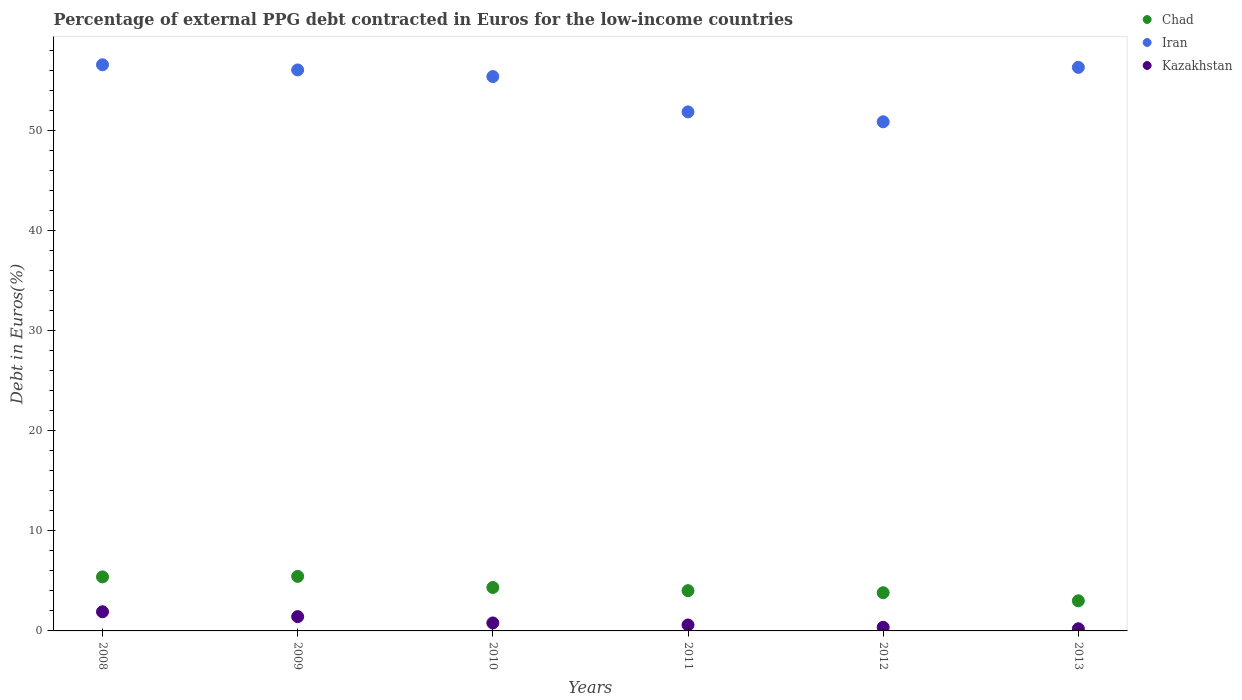Is the number of dotlines equal to the number of legend labels?
Provide a succinct answer. Yes. What is the percentage of external PPG debt contracted in Euros in Chad in 2012?
Your answer should be very brief. 3.82. Across all years, what is the maximum percentage of external PPG debt contracted in Euros in Iran?
Keep it short and to the point. 56.53. Across all years, what is the minimum percentage of external PPG debt contracted in Euros in Chad?
Your response must be concise. 3.01. In which year was the percentage of external PPG debt contracted in Euros in Kazakhstan maximum?
Your answer should be compact. 2008. What is the total percentage of external PPG debt contracted in Euros in Chad in the graph?
Provide a short and direct response. 26.02. What is the difference between the percentage of external PPG debt contracted in Euros in Iran in 2009 and that in 2011?
Keep it short and to the point. 4.19. What is the difference between the percentage of external PPG debt contracted in Euros in Iran in 2011 and the percentage of external PPG debt contracted in Euros in Kazakhstan in 2012?
Your answer should be very brief. 51.47. What is the average percentage of external PPG debt contracted in Euros in Kazakhstan per year?
Provide a short and direct response. 0.88. In the year 2012, what is the difference between the percentage of external PPG debt contracted in Euros in Chad and percentage of external PPG debt contracted in Euros in Iran?
Give a very brief answer. -47.02. In how many years, is the percentage of external PPG debt contracted in Euros in Chad greater than 42 %?
Give a very brief answer. 0. What is the ratio of the percentage of external PPG debt contracted in Euros in Chad in 2010 to that in 2011?
Provide a succinct answer. 1.08. Is the percentage of external PPG debt contracted in Euros in Chad in 2009 less than that in 2012?
Provide a succinct answer. No. Is the difference between the percentage of external PPG debt contracted in Euros in Chad in 2011 and 2013 greater than the difference between the percentage of external PPG debt contracted in Euros in Iran in 2011 and 2013?
Provide a short and direct response. Yes. What is the difference between the highest and the second highest percentage of external PPG debt contracted in Euros in Chad?
Keep it short and to the point. 0.05. What is the difference between the highest and the lowest percentage of external PPG debt contracted in Euros in Kazakhstan?
Your response must be concise. 1.7. Is the percentage of external PPG debt contracted in Euros in Iran strictly greater than the percentage of external PPG debt contracted in Euros in Chad over the years?
Provide a succinct answer. Yes. How many years are there in the graph?
Offer a terse response. 6. What is the difference between two consecutive major ticks on the Y-axis?
Make the answer very short. 10. Does the graph contain any zero values?
Offer a terse response. No. Does the graph contain grids?
Provide a succinct answer. No. How many legend labels are there?
Offer a very short reply. 3. How are the legend labels stacked?
Make the answer very short. Vertical. What is the title of the graph?
Your answer should be compact. Percentage of external PPG debt contracted in Euros for the low-income countries. Does "Antigua and Barbuda" appear as one of the legend labels in the graph?
Offer a terse response. No. What is the label or title of the X-axis?
Provide a short and direct response. Years. What is the label or title of the Y-axis?
Provide a succinct answer. Debt in Euros(%). What is the Debt in Euros(%) of Chad in 2008?
Your response must be concise. 5.39. What is the Debt in Euros(%) of Iran in 2008?
Provide a short and direct response. 56.53. What is the Debt in Euros(%) of Kazakhstan in 2008?
Offer a terse response. 1.91. What is the Debt in Euros(%) of Chad in 2009?
Provide a short and direct response. 5.44. What is the Debt in Euros(%) in Iran in 2009?
Offer a very short reply. 56.01. What is the Debt in Euros(%) in Kazakhstan in 2009?
Your response must be concise. 1.43. What is the Debt in Euros(%) of Chad in 2010?
Keep it short and to the point. 4.34. What is the Debt in Euros(%) of Iran in 2010?
Provide a short and direct response. 55.35. What is the Debt in Euros(%) in Kazakhstan in 2010?
Ensure brevity in your answer.  0.8. What is the Debt in Euros(%) in Chad in 2011?
Your response must be concise. 4.02. What is the Debt in Euros(%) in Iran in 2011?
Provide a short and direct response. 51.83. What is the Debt in Euros(%) of Kazakhstan in 2011?
Keep it short and to the point. 0.59. What is the Debt in Euros(%) of Chad in 2012?
Keep it short and to the point. 3.82. What is the Debt in Euros(%) of Iran in 2012?
Keep it short and to the point. 50.84. What is the Debt in Euros(%) of Kazakhstan in 2012?
Your response must be concise. 0.36. What is the Debt in Euros(%) in Chad in 2013?
Your answer should be compact. 3.01. What is the Debt in Euros(%) of Iran in 2013?
Keep it short and to the point. 56.27. What is the Debt in Euros(%) of Kazakhstan in 2013?
Ensure brevity in your answer.  0.21. Across all years, what is the maximum Debt in Euros(%) in Chad?
Provide a succinct answer. 5.44. Across all years, what is the maximum Debt in Euros(%) in Iran?
Ensure brevity in your answer.  56.53. Across all years, what is the maximum Debt in Euros(%) in Kazakhstan?
Ensure brevity in your answer.  1.91. Across all years, what is the minimum Debt in Euros(%) in Chad?
Provide a short and direct response. 3.01. Across all years, what is the minimum Debt in Euros(%) of Iran?
Offer a terse response. 50.84. Across all years, what is the minimum Debt in Euros(%) in Kazakhstan?
Make the answer very short. 0.21. What is the total Debt in Euros(%) of Chad in the graph?
Give a very brief answer. 26.02. What is the total Debt in Euros(%) in Iran in the graph?
Your answer should be compact. 326.84. What is the total Debt in Euros(%) of Kazakhstan in the graph?
Ensure brevity in your answer.  5.31. What is the difference between the Debt in Euros(%) in Chad in 2008 and that in 2009?
Your answer should be very brief. -0.05. What is the difference between the Debt in Euros(%) of Iran in 2008 and that in 2009?
Your response must be concise. 0.52. What is the difference between the Debt in Euros(%) in Kazakhstan in 2008 and that in 2009?
Make the answer very short. 0.49. What is the difference between the Debt in Euros(%) in Chad in 2008 and that in 2010?
Provide a short and direct response. 1.06. What is the difference between the Debt in Euros(%) in Iran in 2008 and that in 2010?
Your answer should be compact. 1.18. What is the difference between the Debt in Euros(%) of Kazakhstan in 2008 and that in 2010?
Make the answer very short. 1.12. What is the difference between the Debt in Euros(%) of Chad in 2008 and that in 2011?
Your answer should be very brief. 1.37. What is the difference between the Debt in Euros(%) of Iran in 2008 and that in 2011?
Your answer should be compact. 4.7. What is the difference between the Debt in Euros(%) in Kazakhstan in 2008 and that in 2011?
Ensure brevity in your answer.  1.32. What is the difference between the Debt in Euros(%) of Chad in 2008 and that in 2012?
Give a very brief answer. 1.58. What is the difference between the Debt in Euros(%) in Iran in 2008 and that in 2012?
Provide a succinct answer. 5.69. What is the difference between the Debt in Euros(%) in Kazakhstan in 2008 and that in 2012?
Keep it short and to the point. 1.55. What is the difference between the Debt in Euros(%) in Chad in 2008 and that in 2013?
Your answer should be very brief. 2.39. What is the difference between the Debt in Euros(%) in Iran in 2008 and that in 2013?
Offer a very short reply. 0.26. What is the difference between the Debt in Euros(%) in Kazakhstan in 2008 and that in 2013?
Your answer should be very brief. 1.7. What is the difference between the Debt in Euros(%) in Chad in 2009 and that in 2010?
Provide a short and direct response. 1.11. What is the difference between the Debt in Euros(%) in Iran in 2009 and that in 2010?
Your answer should be compact. 0.66. What is the difference between the Debt in Euros(%) in Kazakhstan in 2009 and that in 2010?
Make the answer very short. 0.63. What is the difference between the Debt in Euros(%) of Chad in 2009 and that in 2011?
Provide a short and direct response. 1.42. What is the difference between the Debt in Euros(%) of Iran in 2009 and that in 2011?
Your answer should be very brief. 4.19. What is the difference between the Debt in Euros(%) in Kazakhstan in 2009 and that in 2011?
Offer a terse response. 0.83. What is the difference between the Debt in Euros(%) of Chad in 2009 and that in 2012?
Provide a short and direct response. 1.63. What is the difference between the Debt in Euros(%) in Iran in 2009 and that in 2012?
Provide a succinct answer. 5.18. What is the difference between the Debt in Euros(%) of Kazakhstan in 2009 and that in 2012?
Your response must be concise. 1.06. What is the difference between the Debt in Euros(%) of Chad in 2009 and that in 2013?
Provide a short and direct response. 2.44. What is the difference between the Debt in Euros(%) of Iran in 2009 and that in 2013?
Your response must be concise. -0.26. What is the difference between the Debt in Euros(%) of Kazakhstan in 2009 and that in 2013?
Ensure brevity in your answer.  1.21. What is the difference between the Debt in Euros(%) of Chad in 2010 and that in 2011?
Your answer should be compact. 0.31. What is the difference between the Debt in Euros(%) in Iran in 2010 and that in 2011?
Offer a very short reply. 3.53. What is the difference between the Debt in Euros(%) in Kazakhstan in 2010 and that in 2011?
Offer a terse response. 0.2. What is the difference between the Debt in Euros(%) in Chad in 2010 and that in 2012?
Keep it short and to the point. 0.52. What is the difference between the Debt in Euros(%) in Iran in 2010 and that in 2012?
Give a very brief answer. 4.52. What is the difference between the Debt in Euros(%) in Kazakhstan in 2010 and that in 2012?
Your answer should be compact. 0.43. What is the difference between the Debt in Euros(%) of Chad in 2010 and that in 2013?
Offer a very short reply. 1.33. What is the difference between the Debt in Euros(%) in Iran in 2010 and that in 2013?
Offer a terse response. -0.92. What is the difference between the Debt in Euros(%) in Kazakhstan in 2010 and that in 2013?
Make the answer very short. 0.58. What is the difference between the Debt in Euros(%) in Chad in 2011 and that in 2012?
Make the answer very short. 0.21. What is the difference between the Debt in Euros(%) in Kazakhstan in 2011 and that in 2012?
Keep it short and to the point. 0.23. What is the difference between the Debt in Euros(%) of Chad in 2011 and that in 2013?
Give a very brief answer. 1.01. What is the difference between the Debt in Euros(%) in Iran in 2011 and that in 2013?
Your response must be concise. -4.44. What is the difference between the Debt in Euros(%) in Kazakhstan in 2011 and that in 2013?
Provide a succinct answer. 0.38. What is the difference between the Debt in Euros(%) of Chad in 2012 and that in 2013?
Your response must be concise. 0.81. What is the difference between the Debt in Euros(%) in Iran in 2012 and that in 2013?
Provide a succinct answer. -5.43. What is the difference between the Debt in Euros(%) in Kazakhstan in 2012 and that in 2013?
Ensure brevity in your answer.  0.15. What is the difference between the Debt in Euros(%) in Chad in 2008 and the Debt in Euros(%) in Iran in 2009?
Provide a succinct answer. -50.62. What is the difference between the Debt in Euros(%) in Chad in 2008 and the Debt in Euros(%) in Kazakhstan in 2009?
Offer a very short reply. 3.97. What is the difference between the Debt in Euros(%) in Iran in 2008 and the Debt in Euros(%) in Kazakhstan in 2009?
Provide a succinct answer. 55.1. What is the difference between the Debt in Euros(%) in Chad in 2008 and the Debt in Euros(%) in Iran in 2010?
Provide a short and direct response. -49.96. What is the difference between the Debt in Euros(%) in Chad in 2008 and the Debt in Euros(%) in Kazakhstan in 2010?
Offer a terse response. 4.6. What is the difference between the Debt in Euros(%) in Iran in 2008 and the Debt in Euros(%) in Kazakhstan in 2010?
Make the answer very short. 55.73. What is the difference between the Debt in Euros(%) of Chad in 2008 and the Debt in Euros(%) of Iran in 2011?
Provide a succinct answer. -46.43. What is the difference between the Debt in Euros(%) in Chad in 2008 and the Debt in Euros(%) in Kazakhstan in 2011?
Ensure brevity in your answer.  4.8. What is the difference between the Debt in Euros(%) of Iran in 2008 and the Debt in Euros(%) of Kazakhstan in 2011?
Your answer should be very brief. 55.94. What is the difference between the Debt in Euros(%) of Chad in 2008 and the Debt in Euros(%) of Iran in 2012?
Your response must be concise. -45.44. What is the difference between the Debt in Euros(%) of Chad in 2008 and the Debt in Euros(%) of Kazakhstan in 2012?
Offer a very short reply. 5.03. What is the difference between the Debt in Euros(%) of Iran in 2008 and the Debt in Euros(%) of Kazakhstan in 2012?
Keep it short and to the point. 56.17. What is the difference between the Debt in Euros(%) of Chad in 2008 and the Debt in Euros(%) of Iran in 2013?
Your response must be concise. -50.88. What is the difference between the Debt in Euros(%) of Chad in 2008 and the Debt in Euros(%) of Kazakhstan in 2013?
Provide a short and direct response. 5.18. What is the difference between the Debt in Euros(%) in Iran in 2008 and the Debt in Euros(%) in Kazakhstan in 2013?
Your answer should be very brief. 56.32. What is the difference between the Debt in Euros(%) of Chad in 2009 and the Debt in Euros(%) of Iran in 2010?
Make the answer very short. -49.91. What is the difference between the Debt in Euros(%) in Chad in 2009 and the Debt in Euros(%) in Kazakhstan in 2010?
Your response must be concise. 4.65. What is the difference between the Debt in Euros(%) in Iran in 2009 and the Debt in Euros(%) in Kazakhstan in 2010?
Provide a succinct answer. 55.22. What is the difference between the Debt in Euros(%) in Chad in 2009 and the Debt in Euros(%) in Iran in 2011?
Give a very brief answer. -46.38. What is the difference between the Debt in Euros(%) in Chad in 2009 and the Debt in Euros(%) in Kazakhstan in 2011?
Provide a short and direct response. 4.85. What is the difference between the Debt in Euros(%) in Iran in 2009 and the Debt in Euros(%) in Kazakhstan in 2011?
Your answer should be compact. 55.42. What is the difference between the Debt in Euros(%) in Chad in 2009 and the Debt in Euros(%) in Iran in 2012?
Provide a succinct answer. -45.39. What is the difference between the Debt in Euros(%) in Chad in 2009 and the Debt in Euros(%) in Kazakhstan in 2012?
Offer a terse response. 5.08. What is the difference between the Debt in Euros(%) in Iran in 2009 and the Debt in Euros(%) in Kazakhstan in 2012?
Provide a short and direct response. 55.65. What is the difference between the Debt in Euros(%) of Chad in 2009 and the Debt in Euros(%) of Iran in 2013?
Your answer should be very brief. -50.83. What is the difference between the Debt in Euros(%) of Chad in 2009 and the Debt in Euros(%) of Kazakhstan in 2013?
Provide a short and direct response. 5.23. What is the difference between the Debt in Euros(%) in Iran in 2009 and the Debt in Euros(%) in Kazakhstan in 2013?
Make the answer very short. 55.8. What is the difference between the Debt in Euros(%) in Chad in 2010 and the Debt in Euros(%) in Iran in 2011?
Your response must be concise. -47.49. What is the difference between the Debt in Euros(%) of Chad in 2010 and the Debt in Euros(%) of Kazakhstan in 2011?
Offer a very short reply. 3.74. What is the difference between the Debt in Euros(%) in Iran in 2010 and the Debt in Euros(%) in Kazakhstan in 2011?
Ensure brevity in your answer.  54.76. What is the difference between the Debt in Euros(%) of Chad in 2010 and the Debt in Euros(%) of Iran in 2012?
Make the answer very short. -46.5. What is the difference between the Debt in Euros(%) in Chad in 2010 and the Debt in Euros(%) in Kazakhstan in 2012?
Ensure brevity in your answer.  3.97. What is the difference between the Debt in Euros(%) of Iran in 2010 and the Debt in Euros(%) of Kazakhstan in 2012?
Make the answer very short. 54.99. What is the difference between the Debt in Euros(%) of Chad in 2010 and the Debt in Euros(%) of Iran in 2013?
Provide a succinct answer. -51.94. What is the difference between the Debt in Euros(%) in Chad in 2010 and the Debt in Euros(%) in Kazakhstan in 2013?
Make the answer very short. 4.12. What is the difference between the Debt in Euros(%) of Iran in 2010 and the Debt in Euros(%) of Kazakhstan in 2013?
Give a very brief answer. 55.14. What is the difference between the Debt in Euros(%) of Chad in 2011 and the Debt in Euros(%) of Iran in 2012?
Provide a short and direct response. -46.82. What is the difference between the Debt in Euros(%) of Chad in 2011 and the Debt in Euros(%) of Kazakhstan in 2012?
Your response must be concise. 3.66. What is the difference between the Debt in Euros(%) of Iran in 2011 and the Debt in Euros(%) of Kazakhstan in 2012?
Make the answer very short. 51.47. What is the difference between the Debt in Euros(%) in Chad in 2011 and the Debt in Euros(%) in Iran in 2013?
Ensure brevity in your answer.  -52.25. What is the difference between the Debt in Euros(%) in Chad in 2011 and the Debt in Euros(%) in Kazakhstan in 2013?
Provide a short and direct response. 3.81. What is the difference between the Debt in Euros(%) of Iran in 2011 and the Debt in Euros(%) of Kazakhstan in 2013?
Provide a succinct answer. 51.61. What is the difference between the Debt in Euros(%) of Chad in 2012 and the Debt in Euros(%) of Iran in 2013?
Provide a succinct answer. -52.46. What is the difference between the Debt in Euros(%) in Chad in 2012 and the Debt in Euros(%) in Kazakhstan in 2013?
Keep it short and to the point. 3.6. What is the difference between the Debt in Euros(%) in Iran in 2012 and the Debt in Euros(%) in Kazakhstan in 2013?
Your answer should be very brief. 50.62. What is the average Debt in Euros(%) in Chad per year?
Your answer should be very brief. 4.34. What is the average Debt in Euros(%) of Iran per year?
Keep it short and to the point. 54.47. What is the average Debt in Euros(%) in Kazakhstan per year?
Keep it short and to the point. 0.88. In the year 2008, what is the difference between the Debt in Euros(%) of Chad and Debt in Euros(%) of Iran?
Keep it short and to the point. -51.14. In the year 2008, what is the difference between the Debt in Euros(%) in Chad and Debt in Euros(%) in Kazakhstan?
Your response must be concise. 3.48. In the year 2008, what is the difference between the Debt in Euros(%) in Iran and Debt in Euros(%) in Kazakhstan?
Give a very brief answer. 54.62. In the year 2009, what is the difference between the Debt in Euros(%) of Chad and Debt in Euros(%) of Iran?
Offer a terse response. -50.57. In the year 2009, what is the difference between the Debt in Euros(%) in Chad and Debt in Euros(%) in Kazakhstan?
Your answer should be compact. 4.02. In the year 2009, what is the difference between the Debt in Euros(%) of Iran and Debt in Euros(%) of Kazakhstan?
Provide a short and direct response. 54.59. In the year 2010, what is the difference between the Debt in Euros(%) of Chad and Debt in Euros(%) of Iran?
Ensure brevity in your answer.  -51.02. In the year 2010, what is the difference between the Debt in Euros(%) in Chad and Debt in Euros(%) in Kazakhstan?
Your answer should be compact. 3.54. In the year 2010, what is the difference between the Debt in Euros(%) of Iran and Debt in Euros(%) of Kazakhstan?
Your answer should be very brief. 54.56. In the year 2011, what is the difference between the Debt in Euros(%) in Chad and Debt in Euros(%) in Iran?
Your response must be concise. -47.81. In the year 2011, what is the difference between the Debt in Euros(%) in Chad and Debt in Euros(%) in Kazakhstan?
Provide a short and direct response. 3.43. In the year 2011, what is the difference between the Debt in Euros(%) in Iran and Debt in Euros(%) in Kazakhstan?
Offer a very short reply. 51.23. In the year 2012, what is the difference between the Debt in Euros(%) of Chad and Debt in Euros(%) of Iran?
Give a very brief answer. -47.02. In the year 2012, what is the difference between the Debt in Euros(%) in Chad and Debt in Euros(%) in Kazakhstan?
Provide a short and direct response. 3.45. In the year 2012, what is the difference between the Debt in Euros(%) of Iran and Debt in Euros(%) of Kazakhstan?
Make the answer very short. 50.47. In the year 2013, what is the difference between the Debt in Euros(%) of Chad and Debt in Euros(%) of Iran?
Offer a very short reply. -53.26. In the year 2013, what is the difference between the Debt in Euros(%) in Chad and Debt in Euros(%) in Kazakhstan?
Provide a succinct answer. 2.79. In the year 2013, what is the difference between the Debt in Euros(%) of Iran and Debt in Euros(%) of Kazakhstan?
Ensure brevity in your answer.  56.06. What is the ratio of the Debt in Euros(%) of Chad in 2008 to that in 2009?
Provide a succinct answer. 0.99. What is the ratio of the Debt in Euros(%) of Iran in 2008 to that in 2009?
Offer a terse response. 1.01. What is the ratio of the Debt in Euros(%) in Kazakhstan in 2008 to that in 2009?
Keep it short and to the point. 1.34. What is the ratio of the Debt in Euros(%) in Chad in 2008 to that in 2010?
Provide a short and direct response. 1.24. What is the ratio of the Debt in Euros(%) of Iran in 2008 to that in 2010?
Give a very brief answer. 1.02. What is the ratio of the Debt in Euros(%) of Kazakhstan in 2008 to that in 2010?
Offer a terse response. 2.4. What is the ratio of the Debt in Euros(%) of Chad in 2008 to that in 2011?
Offer a terse response. 1.34. What is the ratio of the Debt in Euros(%) in Iran in 2008 to that in 2011?
Provide a short and direct response. 1.09. What is the ratio of the Debt in Euros(%) of Kazakhstan in 2008 to that in 2011?
Give a very brief answer. 3.22. What is the ratio of the Debt in Euros(%) of Chad in 2008 to that in 2012?
Your answer should be very brief. 1.41. What is the ratio of the Debt in Euros(%) in Iran in 2008 to that in 2012?
Provide a short and direct response. 1.11. What is the ratio of the Debt in Euros(%) of Kazakhstan in 2008 to that in 2012?
Ensure brevity in your answer.  5.28. What is the ratio of the Debt in Euros(%) of Chad in 2008 to that in 2013?
Offer a very short reply. 1.79. What is the ratio of the Debt in Euros(%) of Iran in 2008 to that in 2013?
Provide a short and direct response. 1. What is the ratio of the Debt in Euros(%) in Kazakhstan in 2008 to that in 2013?
Ensure brevity in your answer.  8.93. What is the ratio of the Debt in Euros(%) of Chad in 2009 to that in 2010?
Offer a very short reply. 1.26. What is the ratio of the Debt in Euros(%) of Iran in 2009 to that in 2010?
Your answer should be very brief. 1.01. What is the ratio of the Debt in Euros(%) in Kazakhstan in 2009 to that in 2010?
Make the answer very short. 1.79. What is the ratio of the Debt in Euros(%) in Chad in 2009 to that in 2011?
Offer a very short reply. 1.35. What is the ratio of the Debt in Euros(%) of Iran in 2009 to that in 2011?
Provide a succinct answer. 1.08. What is the ratio of the Debt in Euros(%) in Kazakhstan in 2009 to that in 2011?
Provide a succinct answer. 2.4. What is the ratio of the Debt in Euros(%) of Chad in 2009 to that in 2012?
Make the answer very short. 1.43. What is the ratio of the Debt in Euros(%) in Iran in 2009 to that in 2012?
Your response must be concise. 1.1. What is the ratio of the Debt in Euros(%) in Kazakhstan in 2009 to that in 2012?
Ensure brevity in your answer.  3.93. What is the ratio of the Debt in Euros(%) of Chad in 2009 to that in 2013?
Offer a terse response. 1.81. What is the ratio of the Debt in Euros(%) of Kazakhstan in 2009 to that in 2013?
Offer a very short reply. 6.66. What is the ratio of the Debt in Euros(%) in Chad in 2010 to that in 2011?
Give a very brief answer. 1.08. What is the ratio of the Debt in Euros(%) of Iran in 2010 to that in 2011?
Offer a terse response. 1.07. What is the ratio of the Debt in Euros(%) of Kazakhstan in 2010 to that in 2011?
Ensure brevity in your answer.  1.34. What is the ratio of the Debt in Euros(%) in Chad in 2010 to that in 2012?
Ensure brevity in your answer.  1.14. What is the ratio of the Debt in Euros(%) of Iran in 2010 to that in 2012?
Make the answer very short. 1.09. What is the ratio of the Debt in Euros(%) in Kazakhstan in 2010 to that in 2012?
Keep it short and to the point. 2.2. What is the ratio of the Debt in Euros(%) of Chad in 2010 to that in 2013?
Offer a very short reply. 1.44. What is the ratio of the Debt in Euros(%) of Iran in 2010 to that in 2013?
Offer a terse response. 0.98. What is the ratio of the Debt in Euros(%) of Kazakhstan in 2010 to that in 2013?
Offer a terse response. 3.71. What is the ratio of the Debt in Euros(%) in Chad in 2011 to that in 2012?
Give a very brief answer. 1.05. What is the ratio of the Debt in Euros(%) of Iran in 2011 to that in 2012?
Offer a terse response. 1.02. What is the ratio of the Debt in Euros(%) in Kazakhstan in 2011 to that in 2012?
Ensure brevity in your answer.  1.64. What is the ratio of the Debt in Euros(%) of Chad in 2011 to that in 2013?
Provide a succinct answer. 1.34. What is the ratio of the Debt in Euros(%) in Iran in 2011 to that in 2013?
Your response must be concise. 0.92. What is the ratio of the Debt in Euros(%) in Kazakhstan in 2011 to that in 2013?
Keep it short and to the point. 2.77. What is the ratio of the Debt in Euros(%) in Chad in 2012 to that in 2013?
Your response must be concise. 1.27. What is the ratio of the Debt in Euros(%) of Iran in 2012 to that in 2013?
Offer a terse response. 0.9. What is the ratio of the Debt in Euros(%) of Kazakhstan in 2012 to that in 2013?
Provide a short and direct response. 1.69. What is the difference between the highest and the second highest Debt in Euros(%) of Chad?
Ensure brevity in your answer.  0.05. What is the difference between the highest and the second highest Debt in Euros(%) in Iran?
Keep it short and to the point. 0.26. What is the difference between the highest and the second highest Debt in Euros(%) of Kazakhstan?
Make the answer very short. 0.49. What is the difference between the highest and the lowest Debt in Euros(%) in Chad?
Offer a very short reply. 2.44. What is the difference between the highest and the lowest Debt in Euros(%) of Iran?
Offer a very short reply. 5.69. What is the difference between the highest and the lowest Debt in Euros(%) of Kazakhstan?
Offer a very short reply. 1.7. 